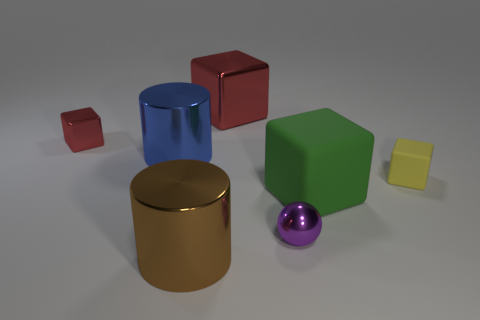Do the cylinder in front of the tiny purple metal sphere and the cube to the left of the big brown thing have the same color?
Ensure brevity in your answer.  No. How many other objects are the same shape as the tiny red thing?
Give a very brief answer. 3. Are there an equal number of balls that are to the right of the small purple metal object and blue objects that are to the right of the green thing?
Offer a terse response. Yes. Do the big cube in front of the yellow cube and the tiny block on the left side of the large green cube have the same material?
Offer a very short reply. No. What number of other objects are there of the same size as the blue object?
Offer a very short reply. 3. How many things are red blocks or big metallic things that are to the left of the big brown cylinder?
Ensure brevity in your answer.  3. Are there an equal number of blue shiny things behind the blue metal thing and red cubes?
Make the answer very short. No. What shape is the blue object that is the same material as the large brown thing?
Make the answer very short. Cylinder. Are there any other balls that have the same color as the tiny ball?
Provide a succinct answer. No. What number of metal things are either red things or green things?
Provide a succinct answer. 2. 